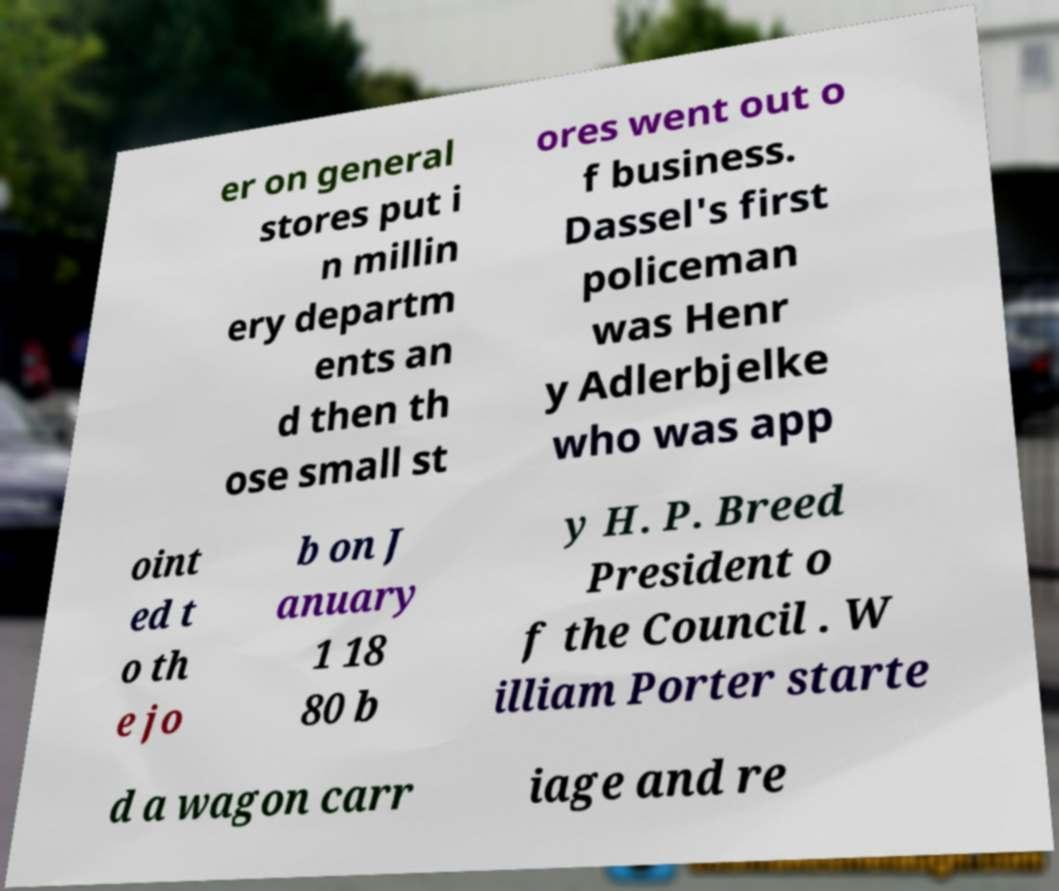I need the written content from this picture converted into text. Can you do that? er on general stores put i n millin ery departm ents an d then th ose small st ores went out o f business. Dassel's first policeman was Henr y Adlerbjelke who was app oint ed t o th e jo b on J anuary 1 18 80 b y H. P. Breed President o f the Council . W illiam Porter starte d a wagon carr iage and re 